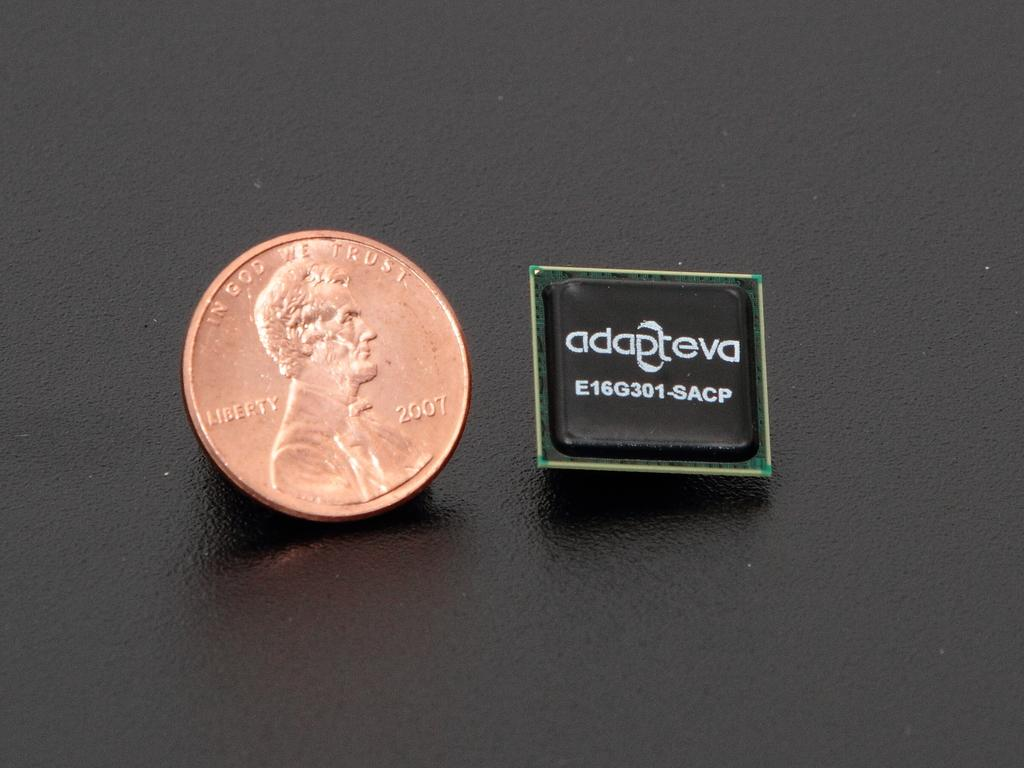<image>
Offer a succinct explanation of the picture presented. Adapteva the company picturing a 2007 USA penny. 